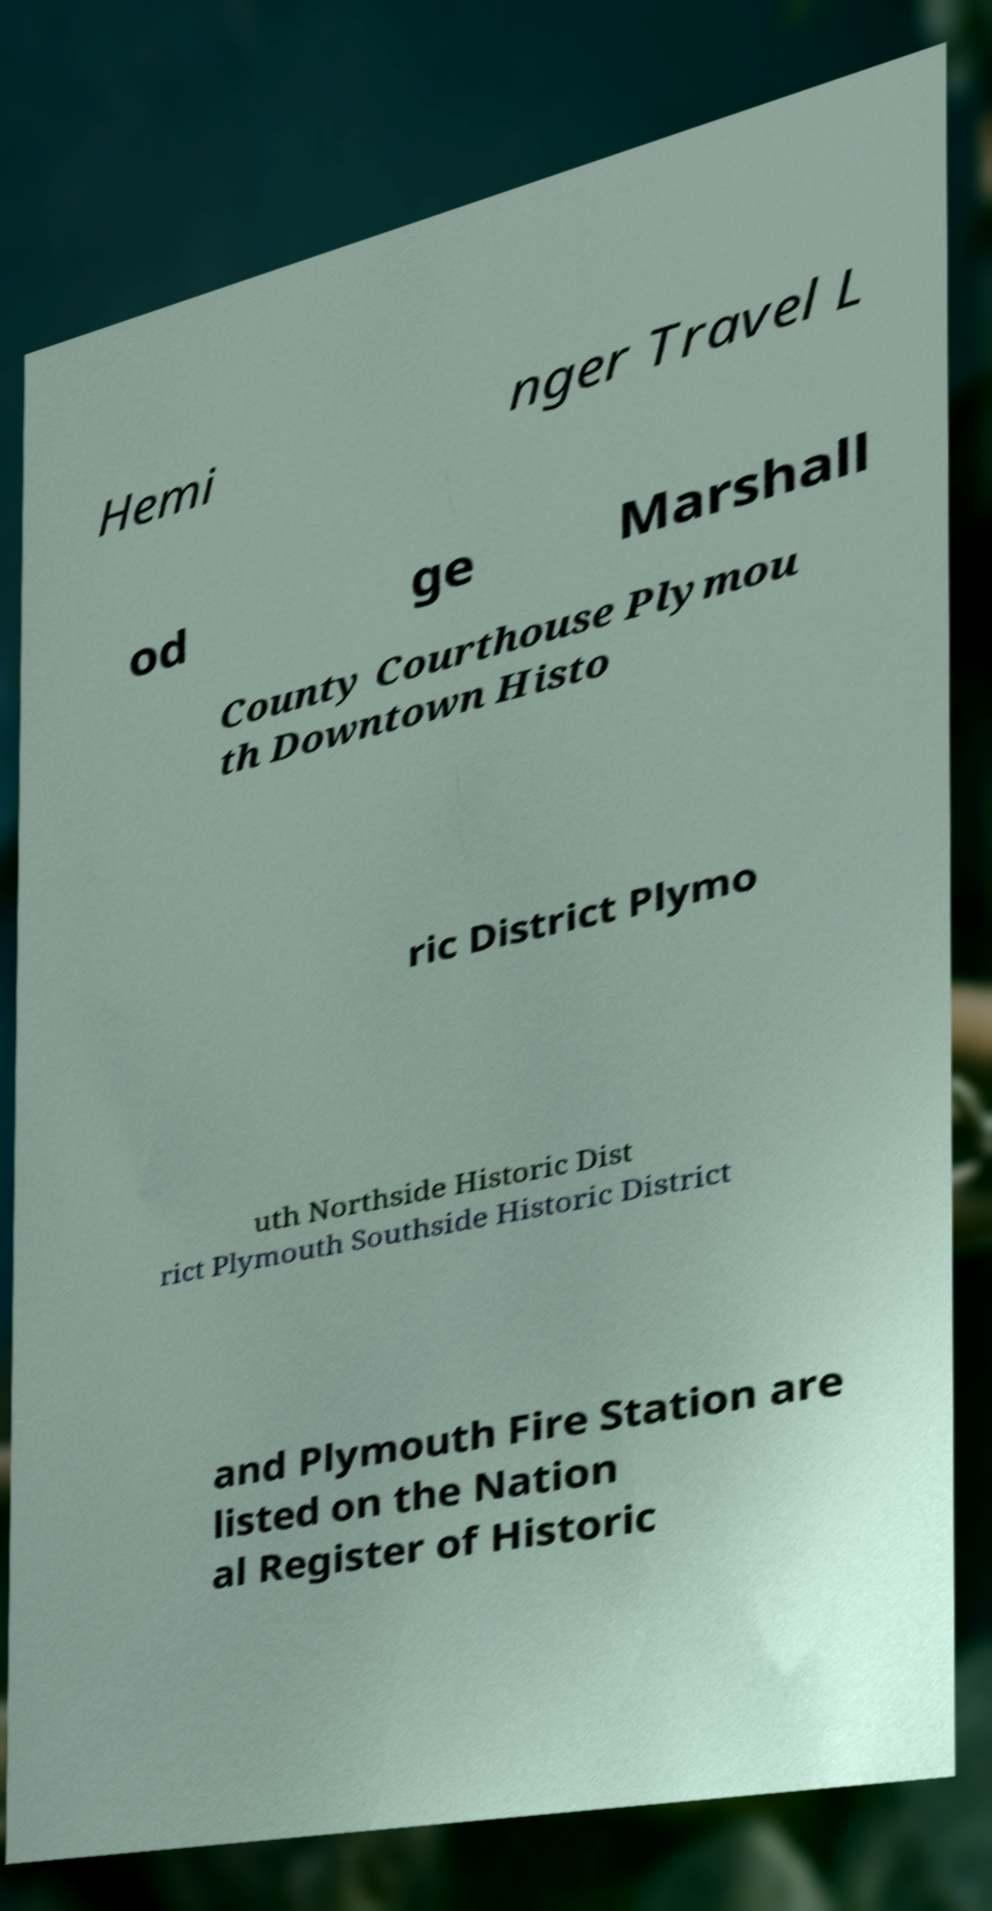Can you accurately transcribe the text from the provided image for me? Hemi nger Travel L od ge Marshall County Courthouse Plymou th Downtown Histo ric District Plymo uth Northside Historic Dist rict Plymouth Southside Historic District and Plymouth Fire Station are listed on the Nation al Register of Historic 